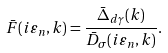Convert formula to latex. <formula><loc_0><loc_0><loc_500><loc_500>\bar { F } ( i \varepsilon _ { n } , { k } ) = \frac { \bar { \Delta } _ { d \gamma } ( { k } ) } { \bar { D } _ { \sigma } ( i \varepsilon _ { n } , { k } ) } .</formula> 